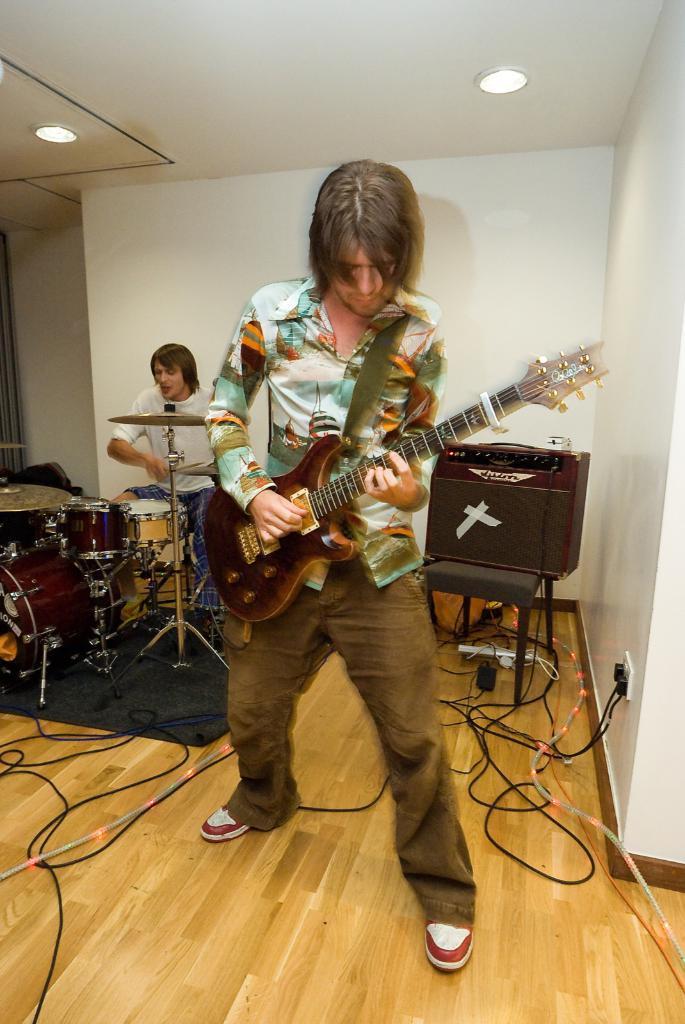In one or two sentences, can you explain what this image depicts? In the given image we can see two persons, one is holding guitar in his hand and other one is having a stick and in front of him there is a musical band. 